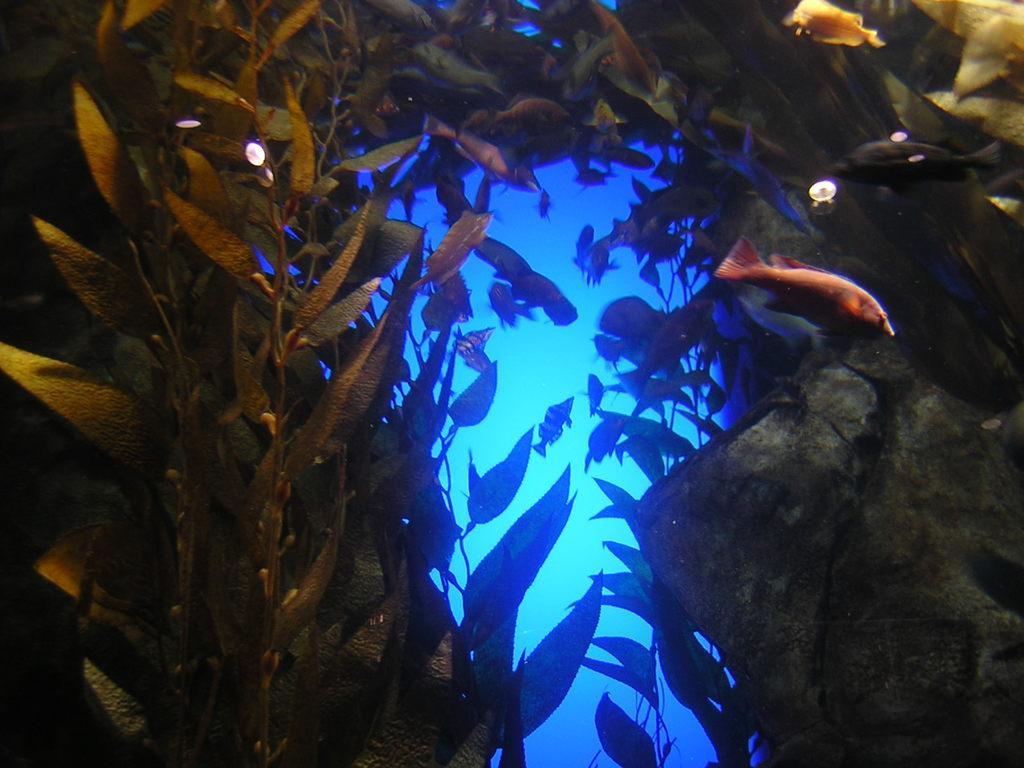In one or two sentences, can you explain what this image depicts? In the picture I can see the fishes and plants in the water. It is looking like a rock on the right side. 